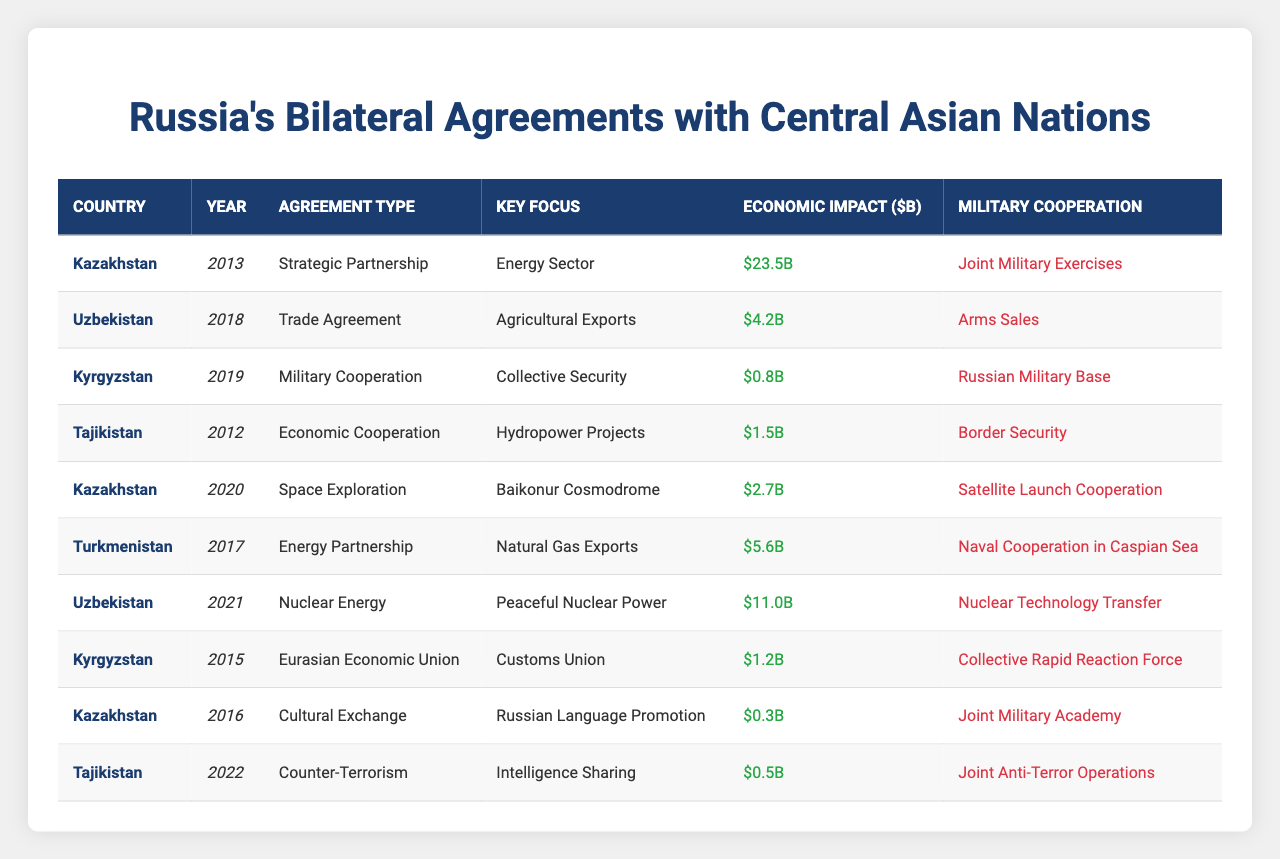What is the highest economic impact agreement in the table? The highest economic impact agreement can be found by comparing the "Economic Impact ($B)" column. The value for Uzbekistan in 2021 is $11.0 billion, which is the largest among all entries.
Answer: $11.0 billion Which country signed a military cooperation agreement in 2019? The table lists Kyrgyzstan as signing a "Military Cooperation" agreement in 2019, focusing on "Collective Security".
Answer: Kyrgyzstan What is the total economic impact of the agreements from Kazakhstan? To calculate this, we look at the economic impacts for Kazakhstan: $23.5B (2013) + $2.7B (2020) + $0.3B (2016) = $26.5B. Therefore, the total economic impact is the sum of these values.
Answer: $26.5 billion Was there a trade agreement signed with Uzbekistan prior to 2018? The table shows that there was no trade agreement listed with Uzbekistan before 2018. The first and only trade agreement in the table for Uzbekistan is from 2018.
Answer: No Which agreement type had the most military cooperation instances? By reviewing the "Military Cooperation" column, the instances of military cooperation agreements are: Kyrgyzstan (2019), Kazakhstan (2013), and Tajikistan (2022), totaling three instances of military cooperation.
Answer: Military Cooperation What percentage of the total economic impact does the agreement with Turkmenistan represent? First, calculate the total economic impact from all agreements: $23.5 + $4.2 + $0.8 + $1.5 + $2.7 + $5.6 + $11.0 + $1.2 + $0.3 + $0.5 = $51.8 billion. Turkmenistan's agreement has an impact of $5.6 billion, so the percentage is ($5.6 / $51.8) * 100 ≈ 10.8%.
Answer: 10.8% How many agreements focus on energy-related sectors? The agreements focusing on energy-related sectors are with Kazakhstan (2013, Energy Sector), Turkmenistan (2017, Natural Gas Exports), and Uzbekistan (2021, Nuclear Energy). This counts as three agreements.
Answer: 3 Is there any agreement with Tajikistan that focuses on military cooperation? The table indicates that Tajikistan has a "Border Security" military cooperation focus through an agreement in 2012 and "Joint Anti-Terror Operations" in 2022, confirming that there are military cooperation agreements with the country.
Answer: Yes What agreement type was signed most recently? The most recent agreement in the table is the "Counter-Terrorism" agreement with Tajikistan in 2022, as it is the entry with the latest year.
Answer: Counter-Terrorism Which country has the smallest economic impact from their agreement listed? Upon examining the "Economic Impact ($B)" values, Kyrgyzstan has the smallest economic impact of $0.8 billion from their 2019 military cooperation agreement.
Answer: Kyrgyzstan If we exclude military agreements, what is the total economic impact of the remaining agreements? Exclude military agreements (Kyrgyzstan in 2019, 2015, and Tajikistan in 2022), we sum: $23.5 (Kazakhstan 2013) + $4.2 (Uzbekistan 2018) + $1.5 (Tajikistan 2012) + $2.7 (Kazakhstan 2020) + $5.6 (Turkmenistan 2017) + $11.0 (Uzbekistan 2021) + $0.3 (Kazakhstan 2016). The total is $49.8 billion.
Answer: $49.8 billion 